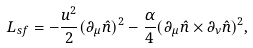<formula> <loc_0><loc_0><loc_500><loc_500>L _ { s f } = - \frac { u ^ { 2 } } { 2 } ( \partial _ { \mu } \hat { n } ) ^ { 2 } - \frac { \alpha } { 4 } ( \partial _ { \mu } \hat { n } \times \partial _ { \nu } \hat { n } ) ^ { 2 } ,</formula> 